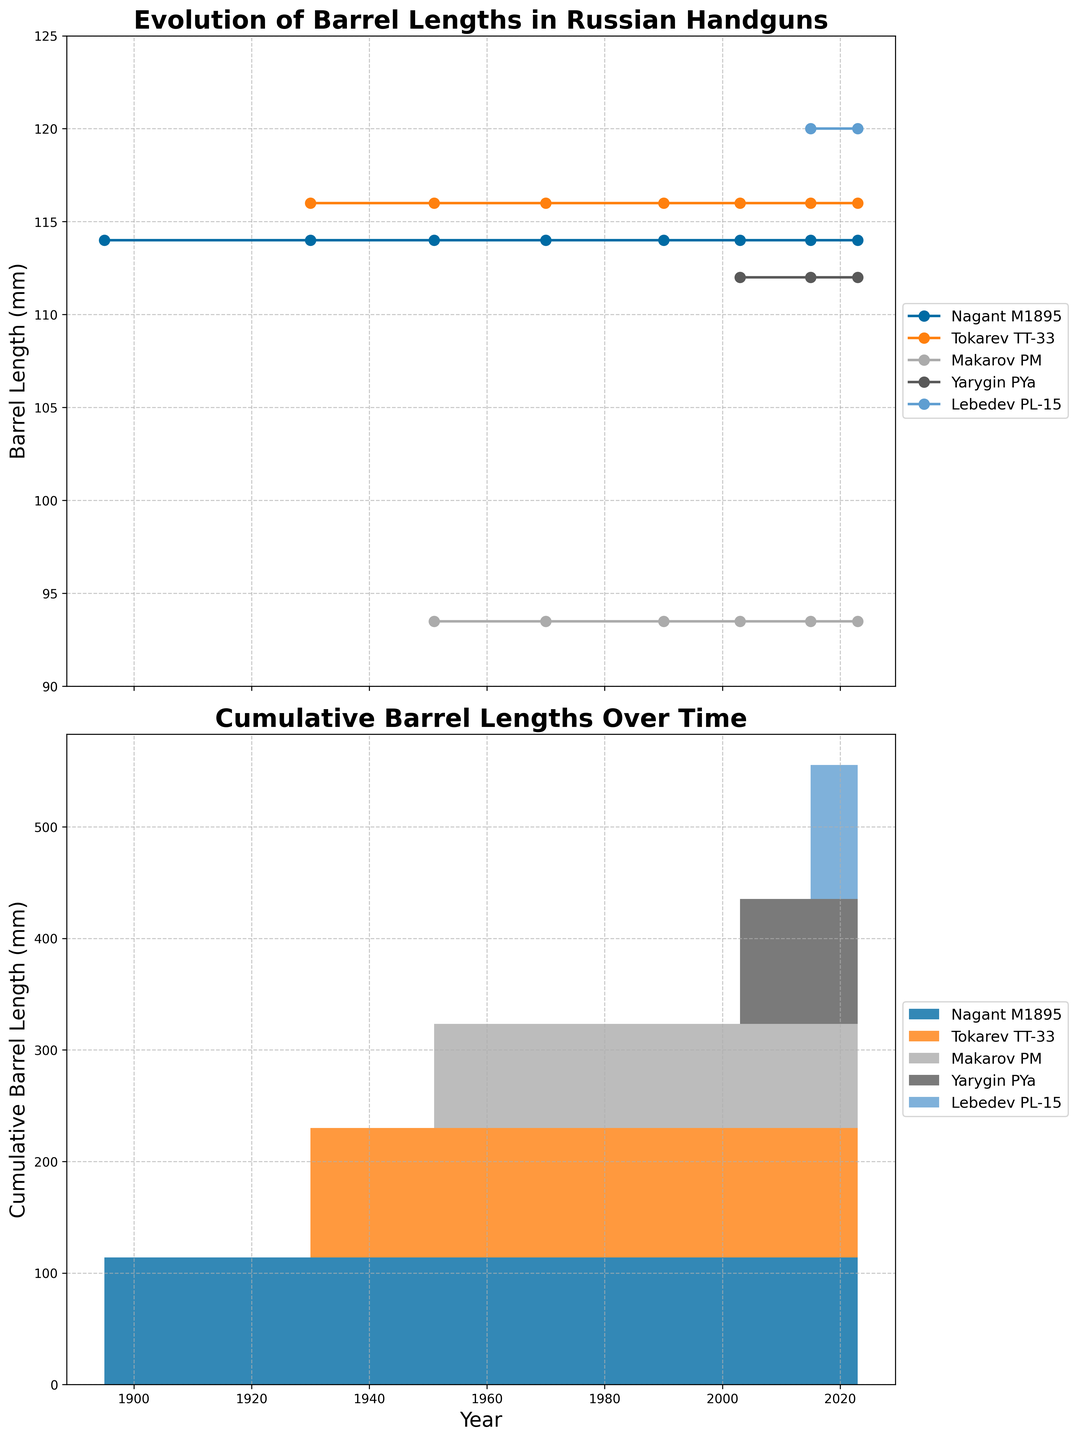What is the title of the line plot? The title of the line plot is "Evolution of Barrel Lengths in Russian Handguns". This is indicated by the large, bold text at the top of the upper subplot.
Answer: Evolution of Barrel Lengths in Russian Handguns What are the units on the y-axis of the line plot? The y-axis of the line plot measures "Barrel Length (mm)". This is marked along the side of the axis.
Answer: Barrel Length (mm) Which handgun has the longest barrel length in the line plot? The Tokarev TT-33 has the longest barrel length at 116 mm as shown by the green line consistently above the others in the plot.
Answer: Tokarev TT-33 How did the barrel length of the Makarov PM change over time? The barrel length of the Makarov PM remained constant at 93.5 mm from 1951 to 2023, as indicated by the horizontal blue line.
Answer: Constant at 93.5 mm Which handgun saw its introduction the latest according to the figure? The Lebedev PL-15 is the latest handgun introduced, with its data appearing from 2015 onwards, as seen in the brown line at the bottom of the plot.
Answer: Lebedev PL-15 In the stacked area plot, during which years did all five handguns have measurable data? All five handguns have measurable data from 2015 to 2023 as seen by the cumulative colored areas for each handgun in the plot covering this time period.
Answer: 2015-2023 What is the combined barrel length of all handguns in 2023 according to the stacked area plot? To find the combined barrel length in 2023, sum individual lengths: Nagant M1895 (114 mm), Tokarev TT-33 (116 mm), Makarov PM (93.5 mm), Yarygin PYa (112 mm), and Lebedev PL-15 (120 mm): 114 + 116 + 93.5 + 112 + 120 = 555.5 mm.
Answer: 555.5 mm Which handgun’s barrel length has remained completely unchanged throughout the recorded years? The Nagant M1895’s barrel length has remained completely unchanged at 114 mm from 1895 to 2023, as indicated by the consistent purple line.
Answer: Nagant M1895 In the line plot, which two handguns have barrel lengths that are most similar across time? The Nagant M1895 and the Tokarev TT-33 have the most similar barrel lengths, both around 114-116 mm, as indicated by their closely positioned purple and green lines.
Answer: Nagant M1895 and Tokarev TT-33 By how much did the barrel length of the Yarygin PYa increase from its introduction to its most recent measurement? The Yarygin PYa's barrel length is constant at 112 mm from its introduction in 2003 to its most recent measurement in 2023. The increase is 0 mm.
Answer: 0 mm 